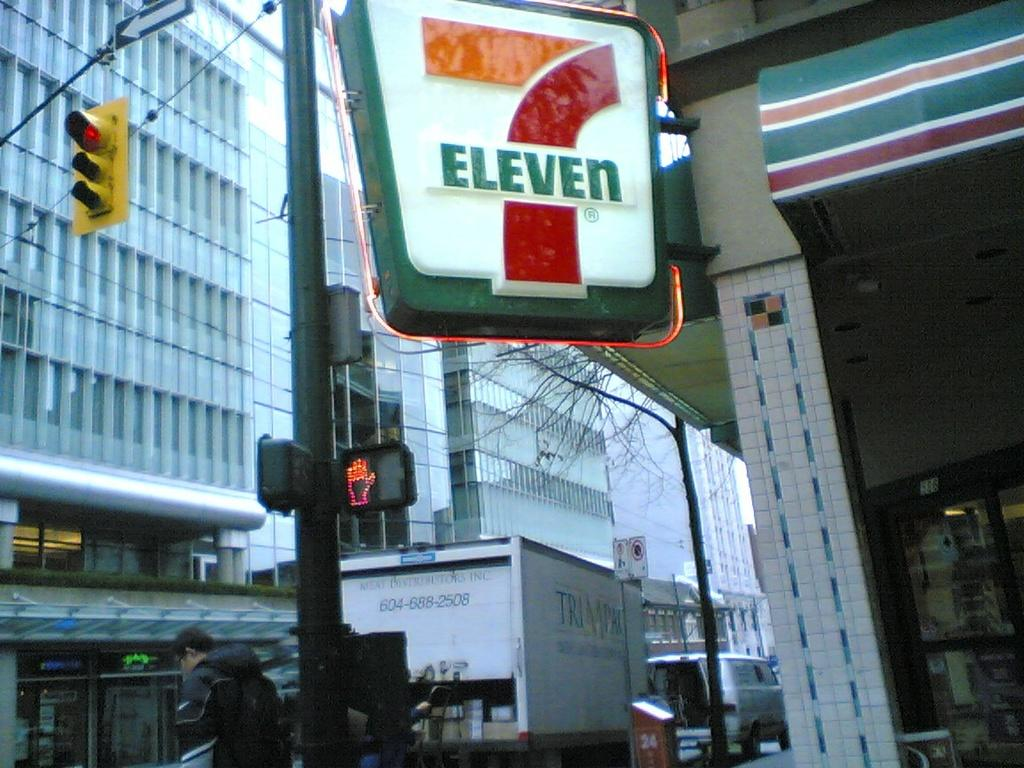What is located in the foreground of the image? There is a sign pole in the foreground. What can be seen in the background of the image? There are vehicles, buildings, and a person in the background. What type of structure is present in the background? There is a stall in the background. What else is present on the left side of the image? There are poles on the left side. How many trees are visible in the image? There are no trees visible in the image. What type of carriage can be seen in the image? There is no carriage present in the image. 